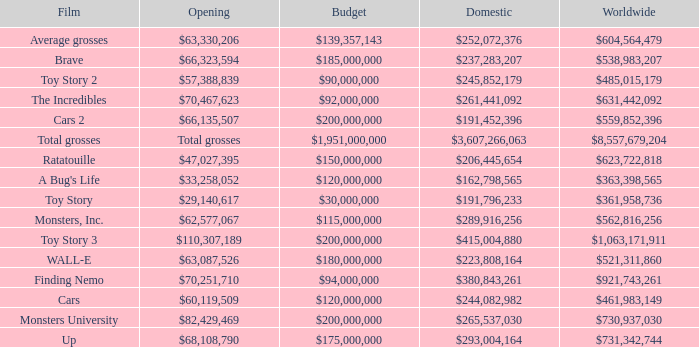WHAT IS THE WORLDWIDE BOX OFFICE FOR BRAVE? $538,983,207. 